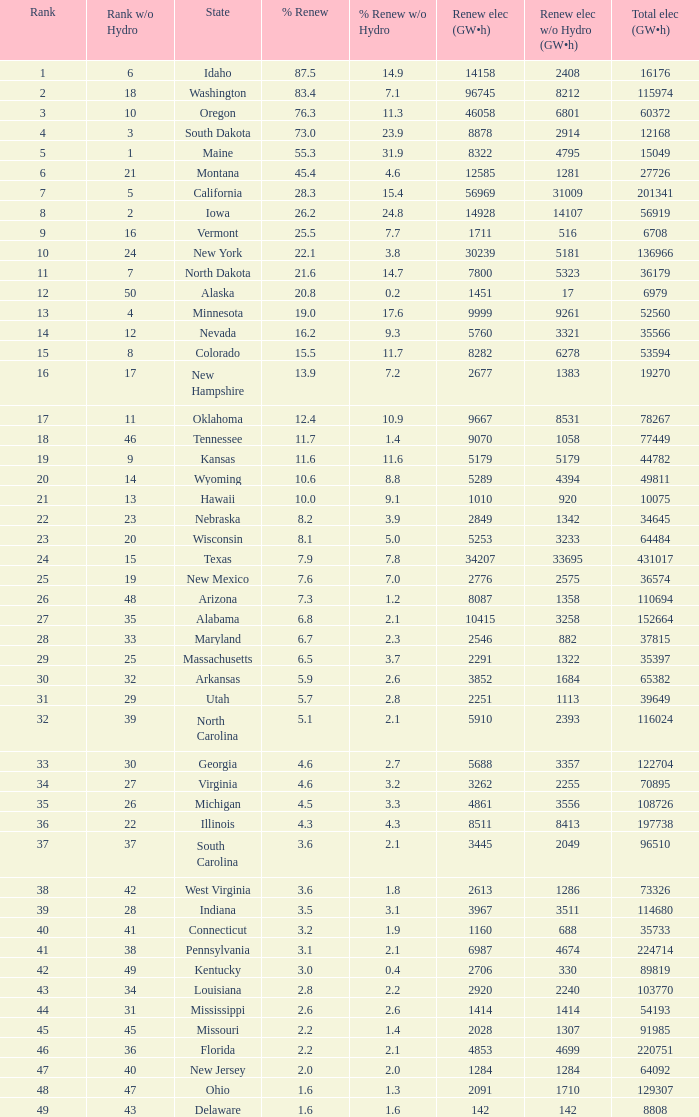What is the least amount of renewable energy, excluding hydrogen power, when the total renewable electricity is 5760 (gw×h)? 3321.0. 